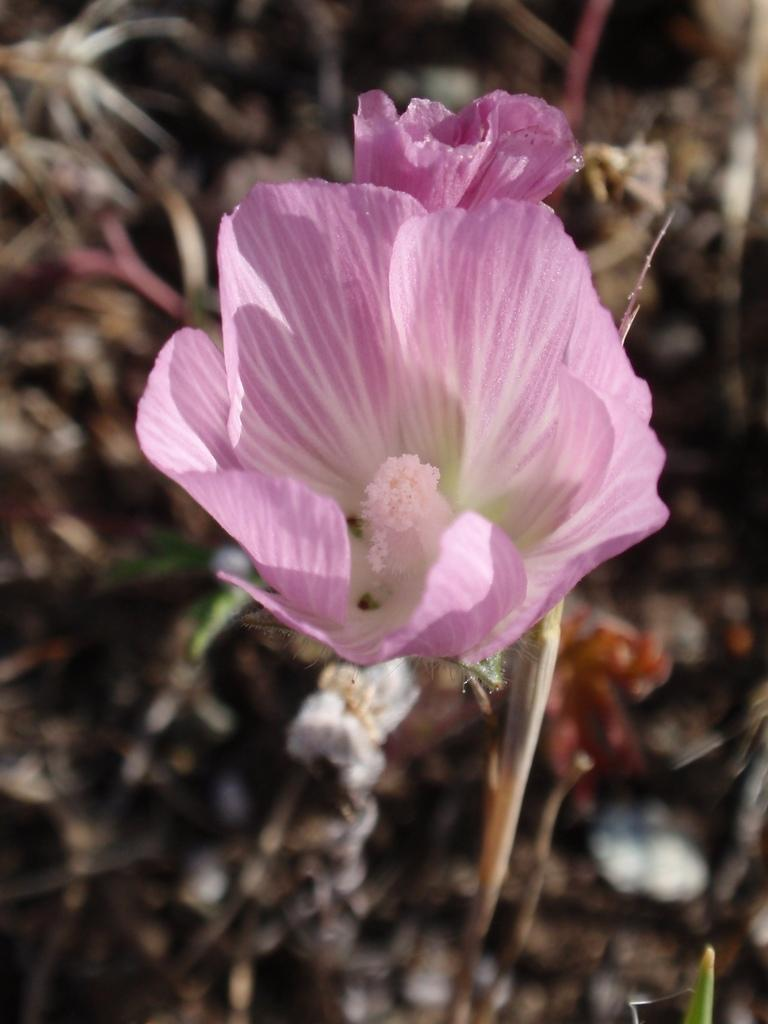What type of flower is in the image? There is a pink and white flower in the image. Can you describe the background of the image? The background is brown in color and appears blurred. What is the position of the governor in the image? There is no governor present in the image, as it only features a pink and white flower and a blurred brown background. 